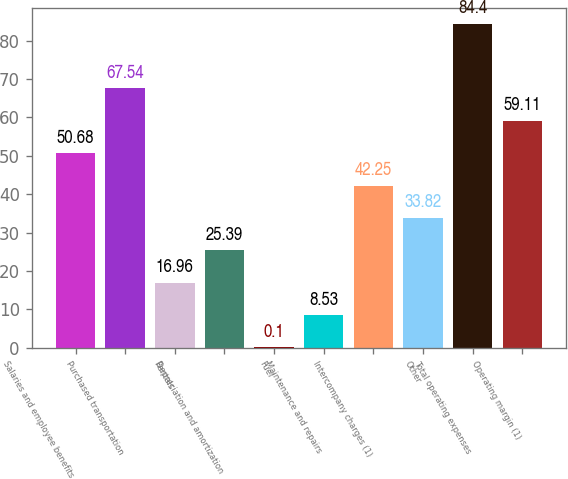Convert chart. <chart><loc_0><loc_0><loc_500><loc_500><bar_chart><fcel>Salaries and employee benefits<fcel>Purchased transportation<fcel>Rentals<fcel>Depreciation and amortization<fcel>Fuel<fcel>Maintenance and repairs<fcel>Intercompany charges (1)<fcel>Other<fcel>Total operating expenses<fcel>Operating margin (1)<nl><fcel>50.68<fcel>67.54<fcel>16.96<fcel>25.39<fcel>0.1<fcel>8.53<fcel>42.25<fcel>33.82<fcel>84.4<fcel>59.11<nl></chart> 